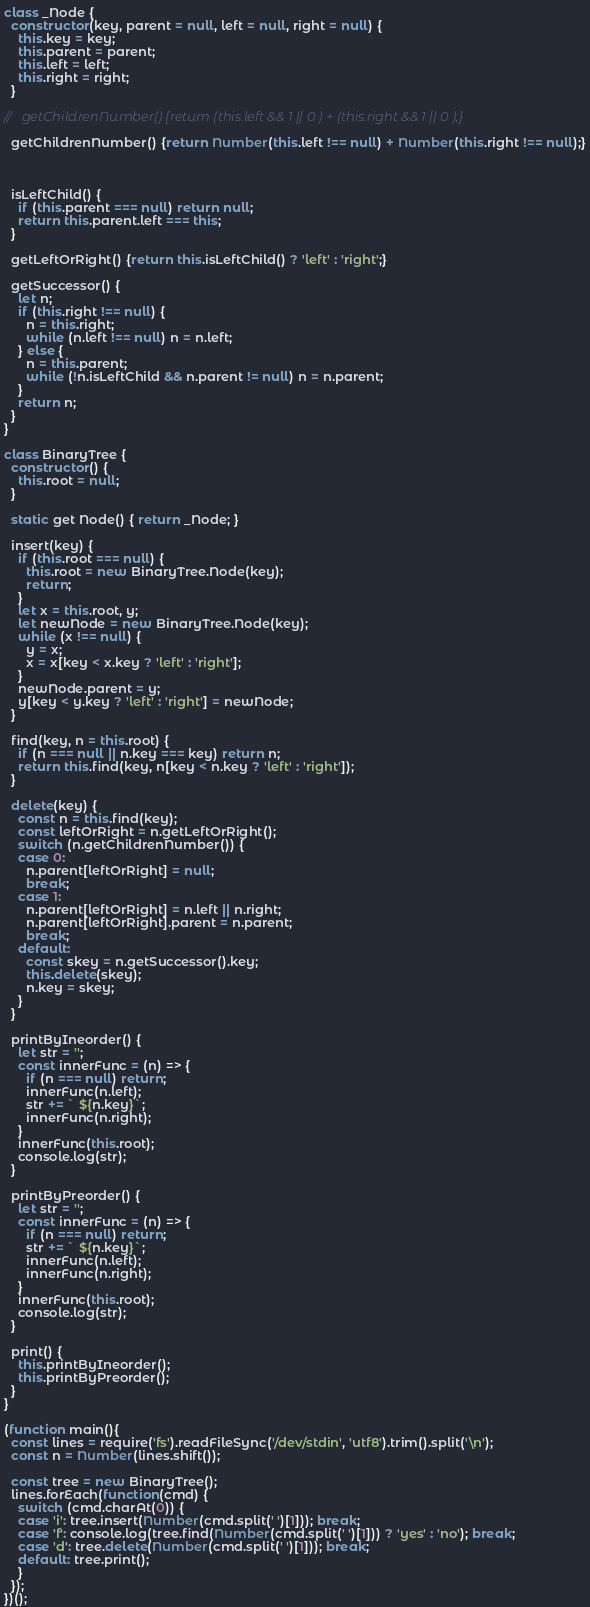<code> <loc_0><loc_0><loc_500><loc_500><_JavaScript_>class _Node {
  constructor(key, parent = null, left = null, right = null) {
    this.key = key;
    this.parent = parent;
    this.left = left;
    this.right = right;
  }

//   getChildrenNumber() {return (this.left && 1 || 0 ) + (this.right && 1 || 0 );}

  getChildrenNumber() {return Number(this.left !== null) + Number(this.right !== null);}



  isLeftChild() {
    if (this.parent === null) return null;
    return this.parent.left === this;
  }

  getLeftOrRight() {return this.isLeftChild() ? 'left' : 'right';}

  getSuccessor() {
    let n;
    if (this.right !== null) {
      n = this.right;
      while (n.left !== null) n = n.left;
    } else {
      n = this.parent;
      while (!n.isLeftChild && n.parent != null) n = n.parent;
    }
    return n;
  }
}

class BinaryTree {
  constructor() {
    this.root = null;
  }

  static get Node() { return _Node; }

  insert(key) {
    if (this.root === null) {
      this.root = new BinaryTree.Node(key);
      return;
    }
    let x = this.root, y;
    let newNode = new BinaryTree.Node(key);
    while (x !== null) {
      y = x;
      x = x[key < x.key ? 'left' : 'right'];
    }
    newNode.parent = y;
    y[key < y.key ? 'left' : 'right'] = newNode;
  }

  find(key, n = this.root) {
    if (n === null || n.key === key) return n;
    return this.find(key, n[key < n.key ? 'left' : 'right']);
  }

  delete(key) {
    const n = this.find(key);
    const leftOrRight = n.getLeftOrRight();
    switch (n.getChildrenNumber()) {
    case 0:
      n.parent[leftOrRight] = null;
      break;
    case 1:
      n.parent[leftOrRight] = n.left || n.right;
      n.parent[leftOrRight].parent = n.parent;
      break;
    default:
      const skey = n.getSuccessor().key;
      this.delete(skey);
      n.key = skey;
    }
  }

  printByIneorder() {
    let str = '';
    const innerFunc = (n) => {
      if (n === null) return;
      innerFunc(n.left);
      str += ` ${n.key}`;
      innerFunc(n.right);
    }
    innerFunc(this.root);
    console.log(str);
  }

  printByPreorder() {
    let str = '';
    const innerFunc = (n) => {
      if (n === null) return;
      str += ` ${n.key}`;
      innerFunc(n.left);
      innerFunc(n.right);
    }
    innerFunc(this.root);
    console.log(str);
  }

  print() {
    this.printByIneorder();
    this.printByPreorder();
  }
}

(function main(){
  const lines = require('fs').readFileSync('/dev/stdin', 'utf8').trim().split('\n');
  const n = Number(lines.shift());

  const tree = new BinaryTree();
  lines.forEach(function(cmd) {
    switch (cmd.charAt(0)) {
    case 'i': tree.insert(Number(cmd.split(' ')[1])); break;
    case 'f': console.log(tree.find(Number(cmd.split(' ')[1])) ? 'yes' : 'no'); break;
    case 'd': tree.delete(Number(cmd.split(' ')[1])); break;
    default: tree.print();
    }
  });
})();

</code> 